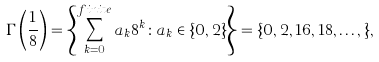Convert formula to latex. <formula><loc_0><loc_0><loc_500><loc_500>\Gamma \left ( \frac { 1 } { 8 } \right ) = \left \{ \sum _ { k = 0 } ^ { f i n i t e } a _ { k } 8 ^ { k } \colon a _ { k } \in \{ 0 , 2 \} \right \} = \{ 0 , 2 , 1 6 , 1 8 , \dots , \} ,</formula> 